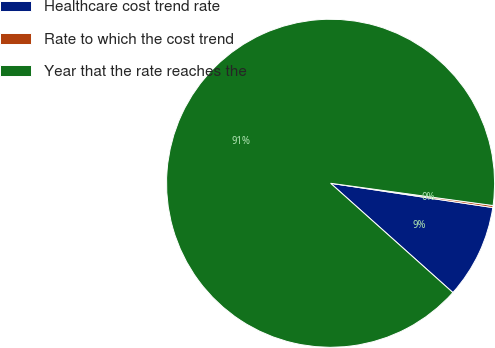Convert chart. <chart><loc_0><loc_0><loc_500><loc_500><pie_chart><fcel>Healthcare cost trend rate<fcel>Rate to which the cost trend<fcel>Year that the rate reaches the<nl><fcel>9.24%<fcel>0.2%<fcel>90.56%<nl></chart> 